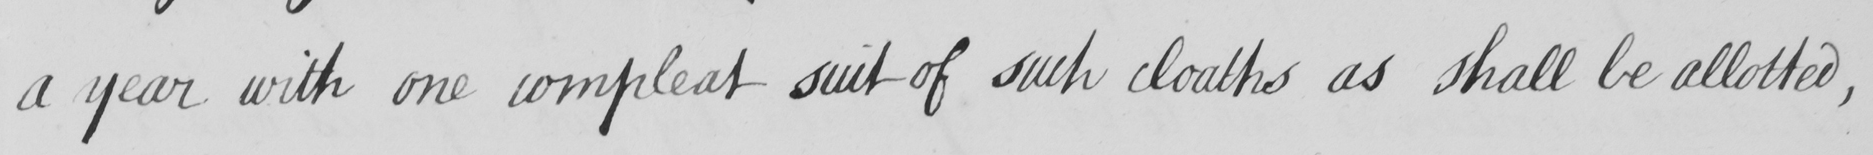Can you tell me what this handwritten text says? a year with one compleat suit of such cloaths as shall be allotted , 